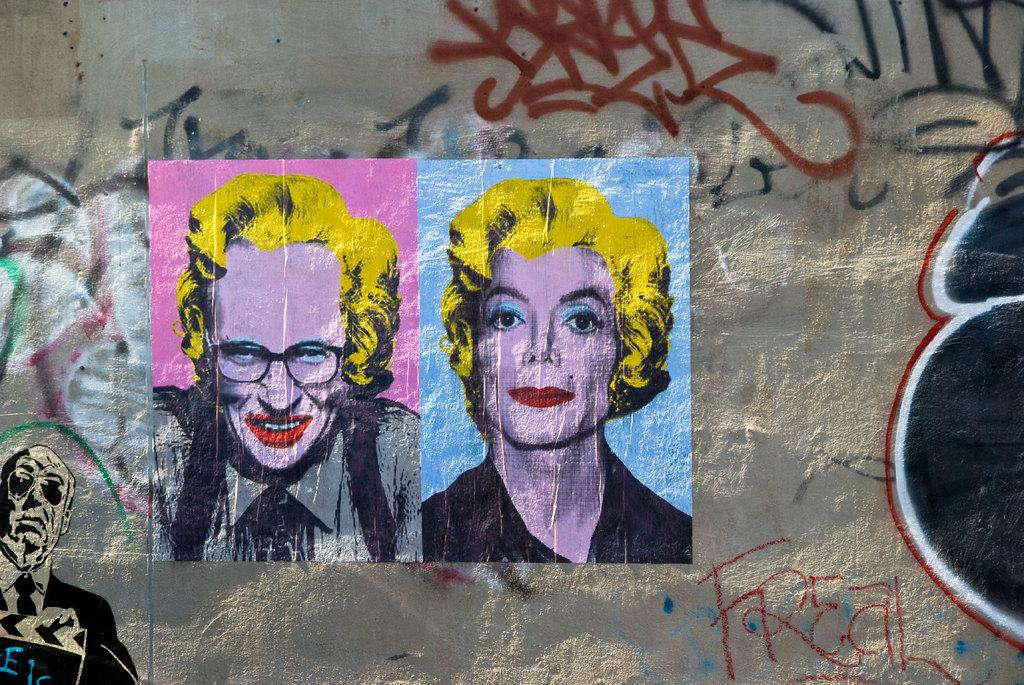What is the main subject in the center of the image? There is a painting on the wall in the center of the image. Can you describe the painting? Unfortunately, the facts provided do not give any details about the painting's content or appearance. What is the painting attached to? The painting is attached to the wall. How does the tongue of the person in the painting taste the water in the image? There is no person or water present in the image, and the painting's content is not described, so it is impossible to answer this question. 